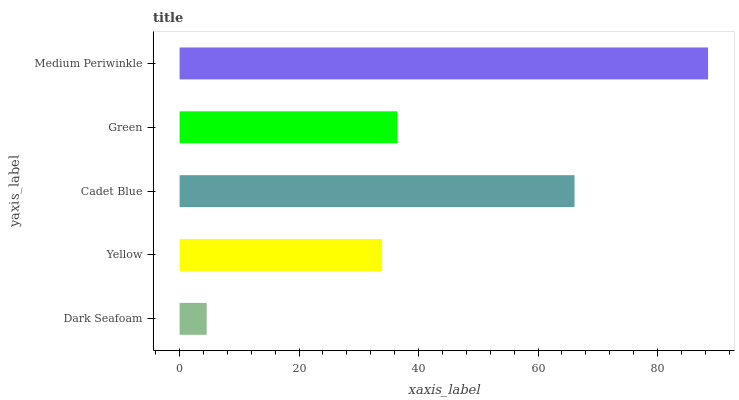Is Dark Seafoam the minimum?
Answer yes or no. Yes. Is Medium Periwinkle the maximum?
Answer yes or no. Yes. Is Yellow the minimum?
Answer yes or no. No. Is Yellow the maximum?
Answer yes or no. No. Is Yellow greater than Dark Seafoam?
Answer yes or no. Yes. Is Dark Seafoam less than Yellow?
Answer yes or no. Yes. Is Dark Seafoam greater than Yellow?
Answer yes or no. No. Is Yellow less than Dark Seafoam?
Answer yes or no. No. Is Green the high median?
Answer yes or no. Yes. Is Green the low median?
Answer yes or no. Yes. Is Cadet Blue the high median?
Answer yes or no. No. Is Cadet Blue the low median?
Answer yes or no. No. 